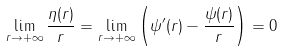Convert formula to latex. <formula><loc_0><loc_0><loc_500><loc_500>\lim _ { r \to + \infty } \frac { \eta ( r ) } r = \lim _ { r \to + \infty } \left ( \psi ^ { \prime } ( r ) - \frac { \psi ( r ) } r \right ) = 0</formula> 